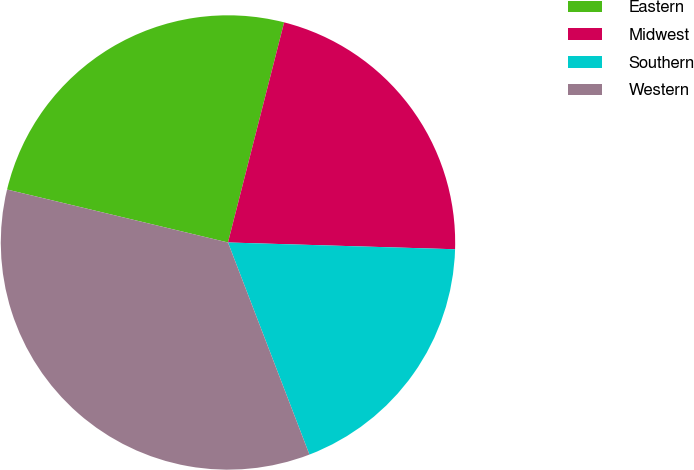Convert chart. <chart><loc_0><loc_0><loc_500><loc_500><pie_chart><fcel>Eastern<fcel>Midwest<fcel>Southern<fcel>Western<nl><fcel>25.23%<fcel>21.5%<fcel>18.69%<fcel>34.58%<nl></chart> 